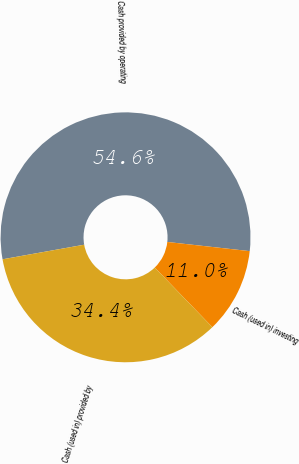Convert chart. <chart><loc_0><loc_0><loc_500><loc_500><pie_chart><fcel>Cash provided by operating<fcel>Cash (used in) investing<fcel>Cash (used in) provided by<nl><fcel>54.58%<fcel>11.01%<fcel>34.41%<nl></chart> 